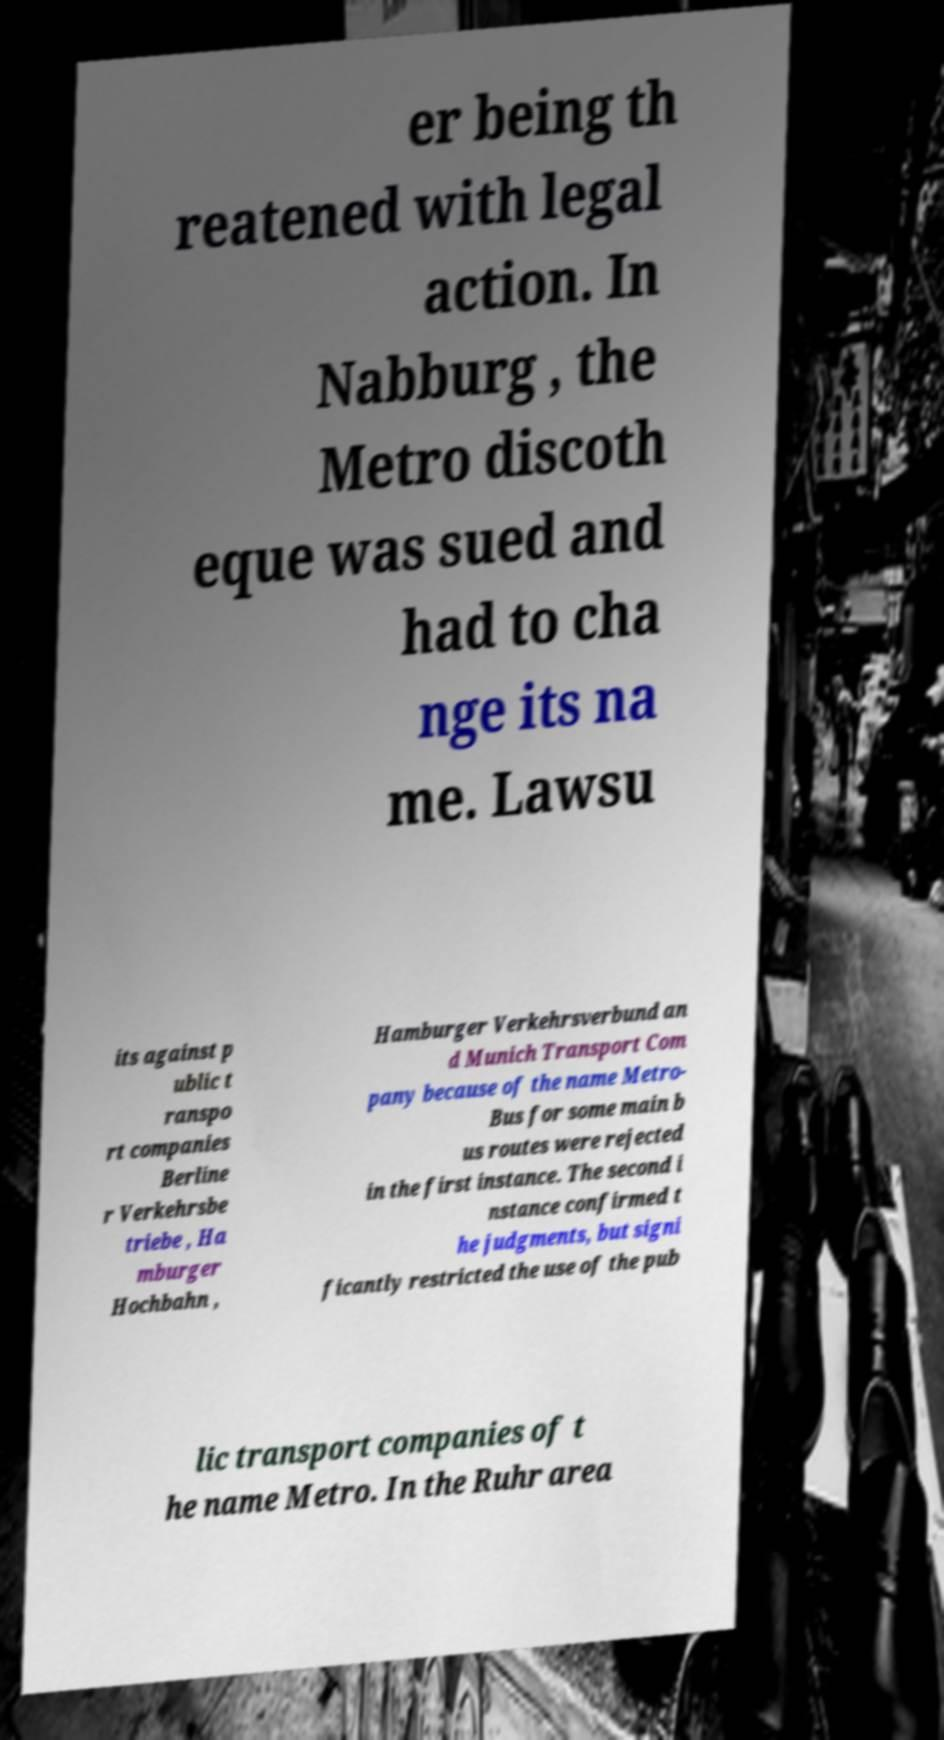What messages or text are displayed in this image? I need them in a readable, typed format. er being th reatened with legal action. In Nabburg , the Metro discoth eque was sued and had to cha nge its na me. Lawsu its against p ublic t ranspo rt companies Berline r Verkehrsbe triebe , Ha mburger Hochbahn , Hamburger Verkehrsverbund an d Munich Transport Com pany because of the name Metro- Bus for some main b us routes were rejected in the first instance. The second i nstance confirmed t he judgments, but signi ficantly restricted the use of the pub lic transport companies of t he name Metro. In the Ruhr area 